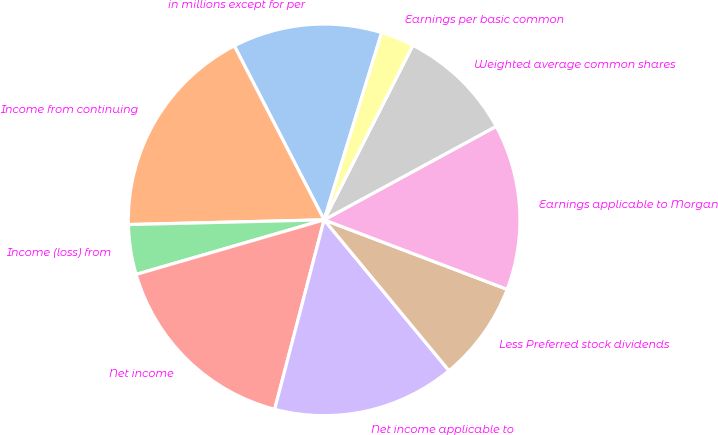Convert chart. <chart><loc_0><loc_0><loc_500><loc_500><pie_chart><fcel>in millions except for per<fcel>Income from continuing<fcel>Income (loss) from<fcel>Net income<fcel>Net income applicable to<fcel>Less Preferred stock dividends<fcel>Earnings applicable to Morgan<fcel>Weighted average common shares<fcel>Earnings per basic common<nl><fcel>12.33%<fcel>17.8%<fcel>4.11%<fcel>16.44%<fcel>15.07%<fcel>8.22%<fcel>13.7%<fcel>9.59%<fcel>2.74%<nl></chart> 